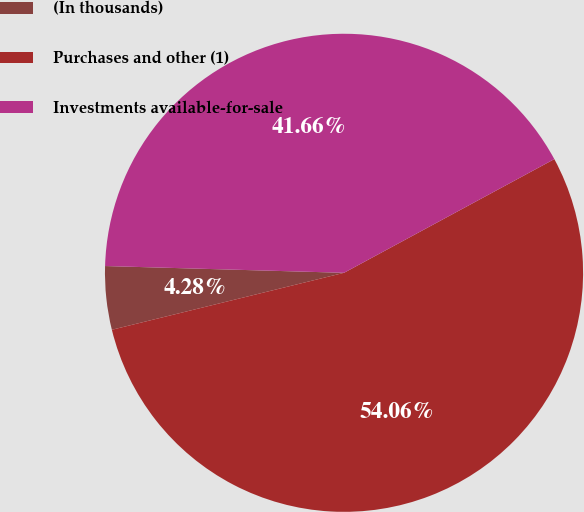Convert chart to OTSL. <chart><loc_0><loc_0><loc_500><loc_500><pie_chart><fcel>(In thousands)<fcel>Purchases and other (1)<fcel>Investments available-for-sale<nl><fcel>4.28%<fcel>54.06%<fcel>41.66%<nl></chart> 